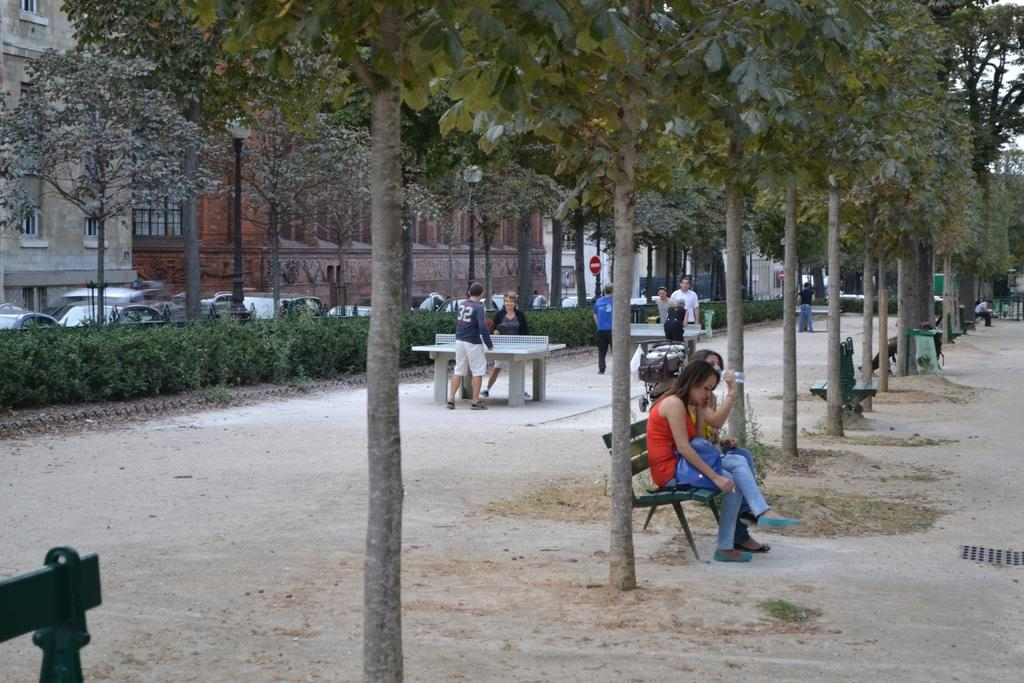What are the people in the image doing? The people in the image are sitting on chairs. What objects can be seen in the hands of the people? There are cards in the image. What type of structures can be seen in the background of the image? There are buildings visible in the image. What type of glove is the fireman wearing in the image? There is no fireman or glove present in the image. Can you tell me how many horses are visible in the image? There are no horses visible in the image. 